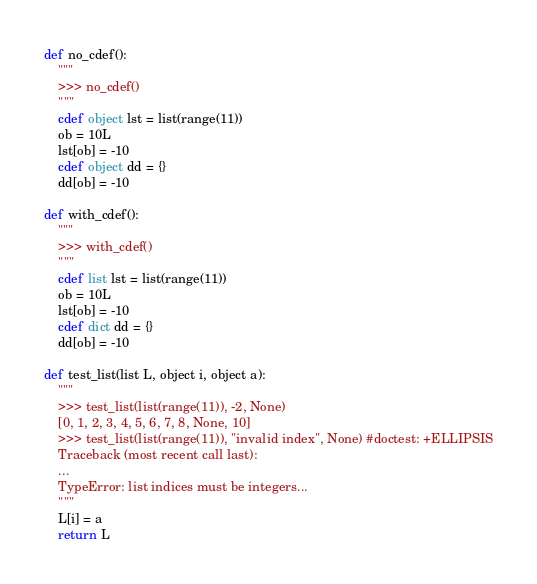<code> <loc_0><loc_0><loc_500><loc_500><_Cython_>def no_cdef():
    """
    >>> no_cdef()
    """
    cdef object lst = list(range(11))
    ob = 10L
    lst[ob] = -10
    cdef object dd = {}
    dd[ob] = -10

def with_cdef():
    """
    >>> with_cdef()
    """
    cdef list lst = list(range(11))
    ob = 10L
    lst[ob] = -10
    cdef dict dd = {}
    dd[ob] = -10

def test_list(list L, object i, object a):
    """
    >>> test_list(list(range(11)), -2, None)
    [0, 1, 2, 3, 4, 5, 6, 7, 8, None, 10]
    >>> test_list(list(range(11)), "invalid index", None) #doctest: +ELLIPSIS
    Traceback (most recent call last):
    ...
    TypeError: list indices must be integers...
    """
    L[i] = a
    return L
</code> 